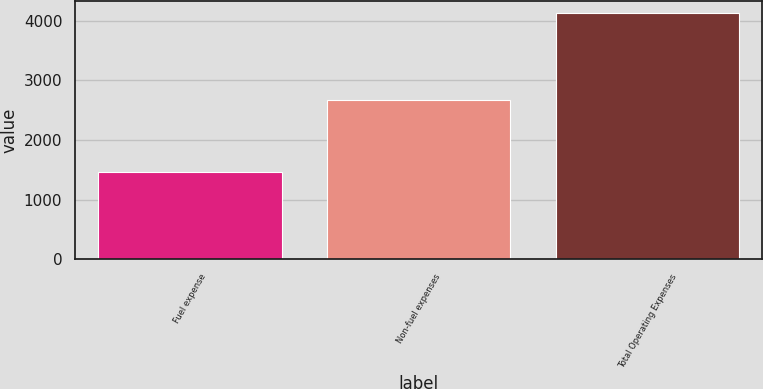Convert chart to OTSL. <chart><loc_0><loc_0><loc_500><loc_500><bar_chart><fcel>Fuel expense<fcel>Non-fuel expenses<fcel>Total Operating Expenses<nl><fcel>1459<fcel>2666<fcel>4125<nl></chart> 